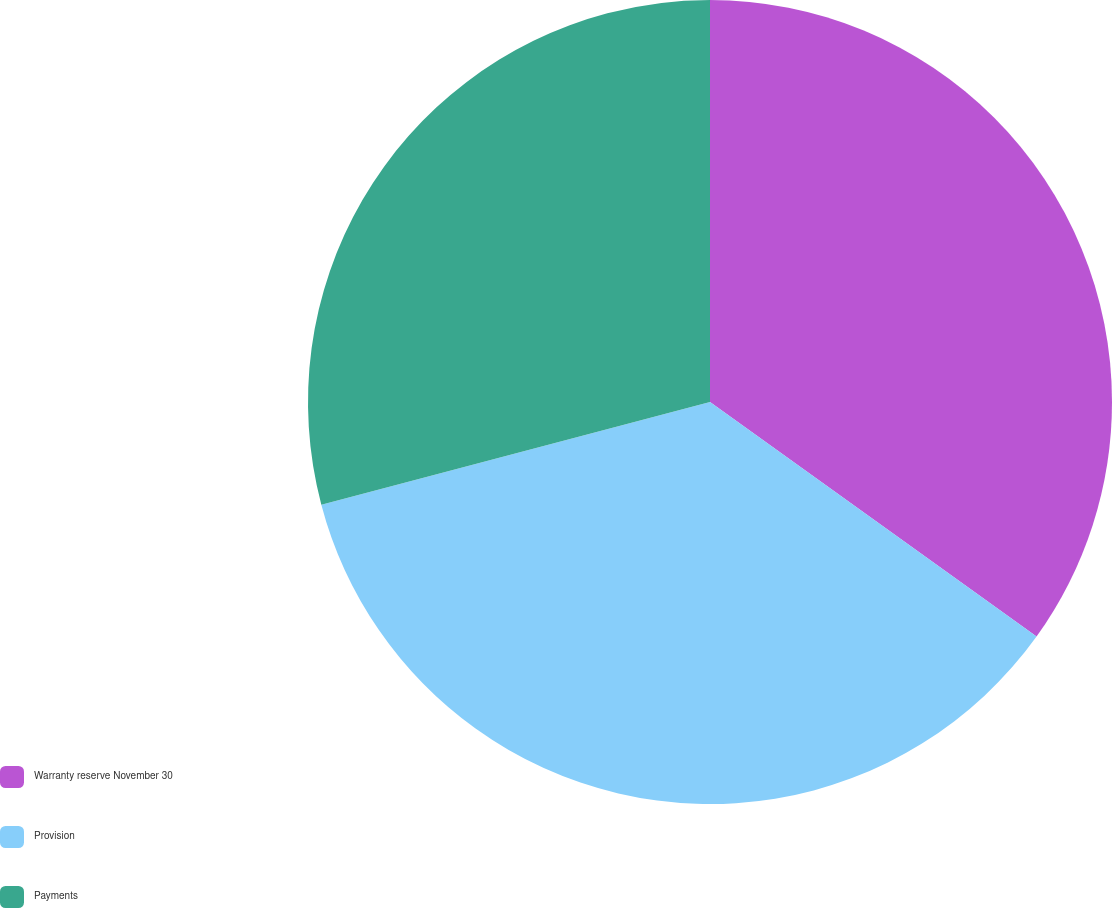<chart> <loc_0><loc_0><loc_500><loc_500><pie_chart><fcel>Warranty reserve November 30<fcel>Provision<fcel>Payments<nl><fcel>34.91%<fcel>35.98%<fcel>29.11%<nl></chart> 